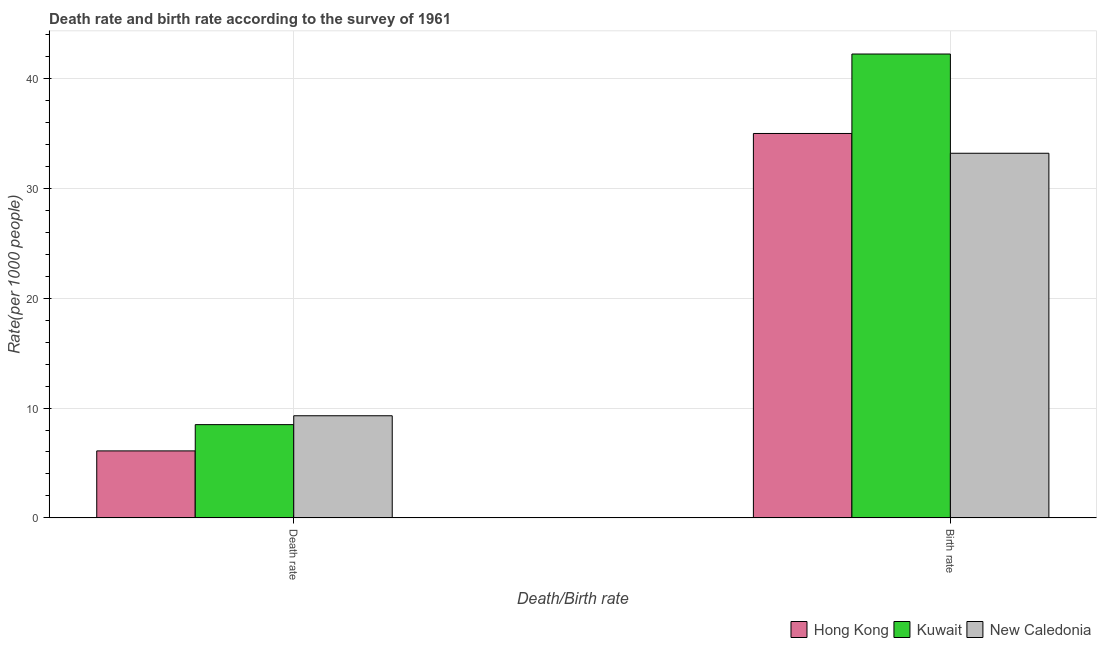Are the number of bars per tick equal to the number of legend labels?
Your answer should be very brief. Yes. Are the number of bars on each tick of the X-axis equal?
Offer a very short reply. Yes. How many bars are there on the 1st tick from the left?
Make the answer very short. 3. What is the label of the 2nd group of bars from the left?
Give a very brief answer. Birth rate. What is the birth rate in Hong Kong?
Your response must be concise. 35. Across all countries, what is the maximum birth rate?
Provide a succinct answer. 42.23. In which country was the birth rate maximum?
Offer a terse response. Kuwait. In which country was the birth rate minimum?
Keep it short and to the point. New Caledonia. What is the total birth rate in the graph?
Ensure brevity in your answer.  110.44. What is the difference between the birth rate in New Caledonia and that in Kuwait?
Offer a very short reply. -9.03. What is the difference between the death rate in Kuwait and the birth rate in Hong Kong?
Provide a succinct answer. -26.51. What is the average death rate per country?
Your answer should be very brief. 7.96. What is the difference between the birth rate and death rate in Kuwait?
Offer a terse response. 33.74. What is the ratio of the death rate in Hong Kong to that in Kuwait?
Your answer should be compact. 0.72. Is the death rate in Kuwait less than that in Hong Kong?
Give a very brief answer. No. In how many countries, is the birth rate greater than the average birth rate taken over all countries?
Offer a very short reply. 1. What does the 1st bar from the left in Death rate represents?
Your answer should be compact. Hong Kong. What does the 1st bar from the right in Birth rate represents?
Ensure brevity in your answer.  New Caledonia. How many bars are there?
Ensure brevity in your answer.  6. Are all the bars in the graph horizontal?
Offer a terse response. No. How many countries are there in the graph?
Provide a succinct answer. 3. Does the graph contain any zero values?
Keep it short and to the point. No. How many legend labels are there?
Ensure brevity in your answer.  3. What is the title of the graph?
Your response must be concise. Death rate and birth rate according to the survey of 1961. What is the label or title of the X-axis?
Offer a terse response. Death/Birth rate. What is the label or title of the Y-axis?
Give a very brief answer. Rate(per 1000 people). What is the Rate(per 1000 people) in Hong Kong in Death rate?
Your answer should be very brief. 6.1. What is the Rate(per 1000 people) of Kuwait in Death rate?
Keep it short and to the point. 8.49. What is the Rate(per 1000 people) of Kuwait in Birth rate?
Provide a succinct answer. 42.23. What is the Rate(per 1000 people) of New Caledonia in Birth rate?
Your answer should be very brief. 33.2. Across all Death/Birth rate, what is the maximum Rate(per 1000 people) of Kuwait?
Provide a short and direct response. 42.23. Across all Death/Birth rate, what is the maximum Rate(per 1000 people) of New Caledonia?
Make the answer very short. 33.2. Across all Death/Birth rate, what is the minimum Rate(per 1000 people) of Kuwait?
Make the answer very short. 8.49. Across all Death/Birth rate, what is the minimum Rate(per 1000 people) in New Caledonia?
Ensure brevity in your answer.  9.3. What is the total Rate(per 1000 people) of Hong Kong in the graph?
Ensure brevity in your answer.  41.1. What is the total Rate(per 1000 people) in Kuwait in the graph?
Give a very brief answer. 50.73. What is the total Rate(per 1000 people) of New Caledonia in the graph?
Provide a succinct answer. 42.5. What is the difference between the Rate(per 1000 people) in Hong Kong in Death rate and that in Birth rate?
Ensure brevity in your answer.  -28.9. What is the difference between the Rate(per 1000 people) of Kuwait in Death rate and that in Birth rate?
Your answer should be compact. -33.74. What is the difference between the Rate(per 1000 people) in New Caledonia in Death rate and that in Birth rate?
Your answer should be compact. -23.9. What is the difference between the Rate(per 1000 people) of Hong Kong in Death rate and the Rate(per 1000 people) of Kuwait in Birth rate?
Ensure brevity in your answer.  -36.13. What is the difference between the Rate(per 1000 people) of Hong Kong in Death rate and the Rate(per 1000 people) of New Caledonia in Birth rate?
Your answer should be very brief. -27.1. What is the difference between the Rate(per 1000 people) of Kuwait in Death rate and the Rate(per 1000 people) of New Caledonia in Birth rate?
Offer a very short reply. -24.71. What is the average Rate(per 1000 people) of Hong Kong per Death/Birth rate?
Keep it short and to the point. 20.55. What is the average Rate(per 1000 people) of Kuwait per Death/Birth rate?
Your answer should be very brief. 25.36. What is the average Rate(per 1000 people) in New Caledonia per Death/Birth rate?
Your answer should be compact. 21.25. What is the difference between the Rate(per 1000 people) in Hong Kong and Rate(per 1000 people) in Kuwait in Death rate?
Provide a short and direct response. -2.39. What is the difference between the Rate(per 1000 people) in Hong Kong and Rate(per 1000 people) in New Caledonia in Death rate?
Offer a very short reply. -3.2. What is the difference between the Rate(per 1000 people) in Kuwait and Rate(per 1000 people) in New Caledonia in Death rate?
Your response must be concise. -0.81. What is the difference between the Rate(per 1000 people) of Hong Kong and Rate(per 1000 people) of Kuwait in Birth rate?
Provide a succinct answer. -7.24. What is the difference between the Rate(per 1000 people) of Hong Kong and Rate(per 1000 people) of New Caledonia in Birth rate?
Keep it short and to the point. 1.8. What is the difference between the Rate(per 1000 people) in Kuwait and Rate(per 1000 people) in New Caledonia in Birth rate?
Your answer should be very brief. 9.04. What is the ratio of the Rate(per 1000 people) in Hong Kong in Death rate to that in Birth rate?
Provide a short and direct response. 0.17. What is the ratio of the Rate(per 1000 people) of Kuwait in Death rate to that in Birth rate?
Your answer should be very brief. 0.2. What is the ratio of the Rate(per 1000 people) of New Caledonia in Death rate to that in Birth rate?
Your answer should be compact. 0.28. What is the difference between the highest and the second highest Rate(per 1000 people) of Hong Kong?
Offer a very short reply. 28.9. What is the difference between the highest and the second highest Rate(per 1000 people) in Kuwait?
Provide a short and direct response. 33.74. What is the difference between the highest and the second highest Rate(per 1000 people) of New Caledonia?
Provide a succinct answer. 23.9. What is the difference between the highest and the lowest Rate(per 1000 people) of Hong Kong?
Your answer should be compact. 28.9. What is the difference between the highest and the lowest Rate(per 1000 people) of Kuwait?
Your answer should be compact. 33.74. What is the difference between the highest and the lowest Rate(per 1000 people) in New Caledonia?
Ensure brevity in your answer.  23.9. 